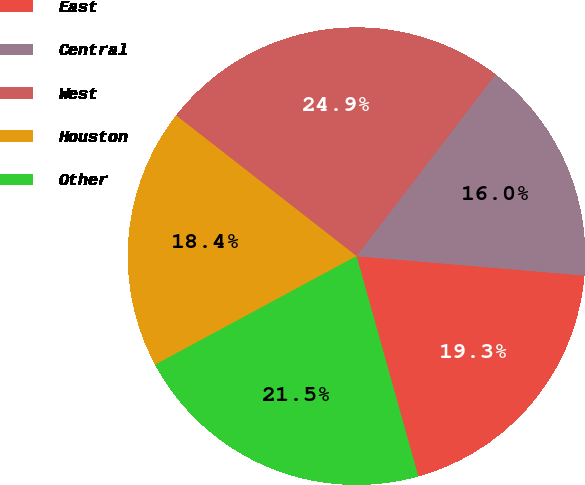<chart> <loc_0><loc_0><loc_500><loc_500><pie_chart><fcel>East<fcel>Central<fcel>West<fcel>Houston<fcel>Other<nl><fcel>19.3%<fcel>15.96%<fcel>24.85%<fcel>18.41%<fcel>21.48%<nl></chart> 